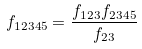<formula> <loc_0><loc_0><loc_500><loc_500>f _ { 1 2 3 4 5 } = \frac { f _ { 1 2 3 } f _ { 2 3 4 5 } } { f _ { 2 3 } }</formula> 